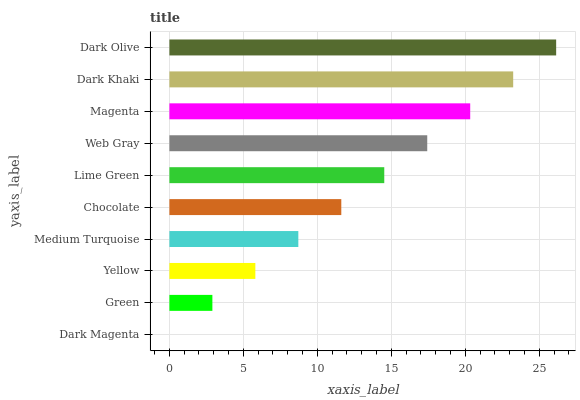Is Dark Magenta the minimum?
Answer yes or no. Yes. Is Dark Olive the maximum?
Answer yes or no. Yes. Is Green the minimum?
Answer yes or no. No. Is Green the maximum?
Answer yes or no. No. Is Green greater than Dark Magenta?
Answer yes or no. Yes. Is Dark Magenta less than Green?
Answer yes or no. Yes. Is Dark Magenta greater than Green?
Answer yes or no. No. Is Green less than Dark Magenta?
Answer yes or no. No. Is Lime Green the high median?
Answer yes or no. Yes. Is Chocolate the low median?
Answer yes or no. Yes. Is Dark Magenta the high median?
Answer yes or no. No. Is Web Gray the low median?
Answer yes or no. No. 